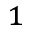<formula> <loc_0><loc_0><loc_500><loc_500>^ { 1 }</formula> 